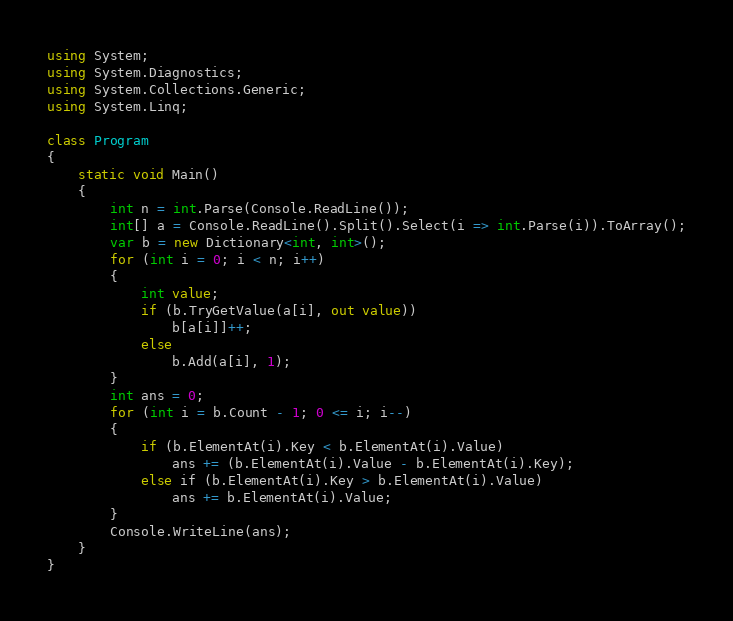<code> <loc_0><loc_0><loc_500><loc_500><_C#_>using System;
using System.Diagnostics;
using System.Collections.Generic;
using System.Linq;

class Program
{
    static void Main()
    {
        int n = int.Parse(Console.ReadLine());
        int[] a = Console.ReadLine().Split().Select(i => int.Parse(i)).ToArray();
        var b = new Dictionary<int, int>();
        for (int i = 0; i < n; i++)
        {
            int value;
            if (b.TryGetValue(a[i], out value))
                b[a[i]]++;
            else
                b.Add(a[i], 1);
        }
        int ans = 0;
        for (int i = b.Count - 1; 0 <= i; i--)
        {
            if (b.ElementAt(i).Key < b.ElementAt(i).Value)
                ans += (b.ElementAt(i).Value - b.ElementAt(i).Key);
            else if (b.ElementAt(i).Key > b.ElementAt(i).Value)
                ans += b.ElementAt(i).Value;
        }
        Console.WriteLine(ans);
    }
}</code> 